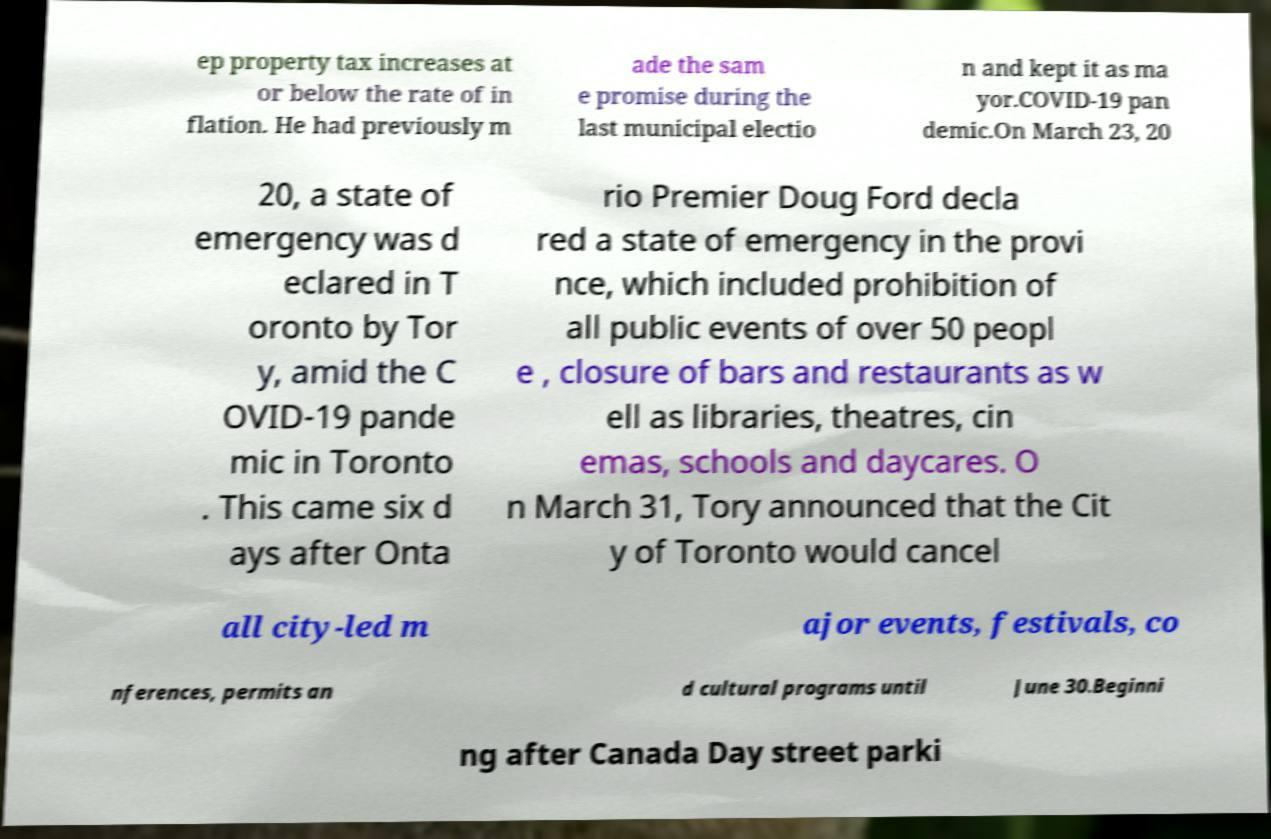Can you read and provide the text displayed in the image?This photo seems to have some interesting text. Can you extract and type it out for me? ep property tax increases at or below the rate of in flation. He had previously m ade the sam e promise during the last municipal electio n and kept it as ma yor.COVID-19 pan demic.On March 23, 20 20, a state of emergency was d eclared in T oronto by Tor y, amid the C OVID-19 pande mic in Toronto . This came six d ays after Onta rio Premier Doug Ford decla red a state of emergency in the provi nce, which included prohibition of all public events of over 50 peopl e , closure of bars and restaurants as w ell as libraries, theatres, cin emas, schools and daycares. O n March 31, Tory announced that the Cit y of Toronto would cancel all city-led m ajor events, festivals, co nferences, permits an d cultural programs until June 30.Beginni ng after Canada Day street parki 